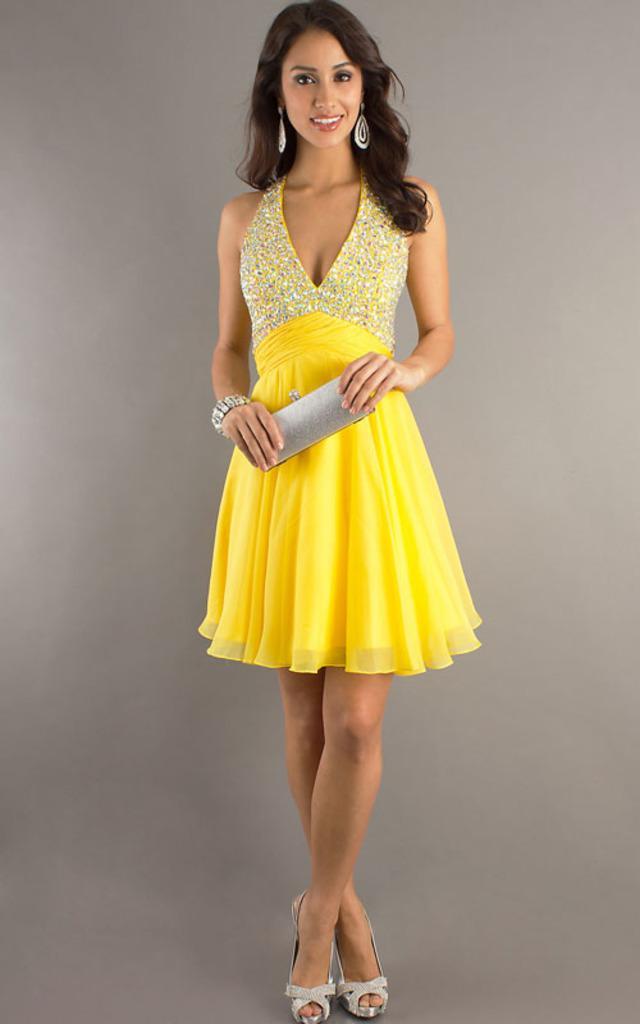Can you describe this image briefly? In this image there is a girl standing with a smile on her face and she is holding a purse in her hand, behind her there is a wall. 